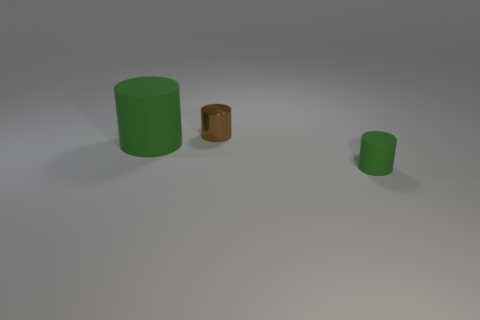There is another cylinder that is the same color as the large rubber cylinder; what is its size?
Keep it short and to the point. Small. Is the metallic object the same color as the small rubber object?
Keep it short and to the point. No. How many things are things in front of the big green rubber thing or green cubes?
Offer a terse response. 1. There is a green object that is right of the big rubber object; is it the same size as the green matte object on the left side of the small rubber cylinder?
Your answer should be compact. No. Are there any other things that are the same material as the small brown cylinder?
Offer a terse response. No. What number of things are green objects that are on the left side of the tiny green rubber cylinder or objects that are behind the big cylinder?
Ensure brevity in your answer.  2. Does the large green thing have the same material as the small thing right of the brown thing?
Offer a terse response. Yes. The object that is behind the tiny green rubber cylinder and in front of the small brown shiny thing has what shape?
Ensure brevity in your answer.  Cylinder. What number of other things are there of the same color as the small rubber cylinder?
Make the answer very short. 1. What is the shape of the brown thing?
Provide a succinct answer. Cylinder. 